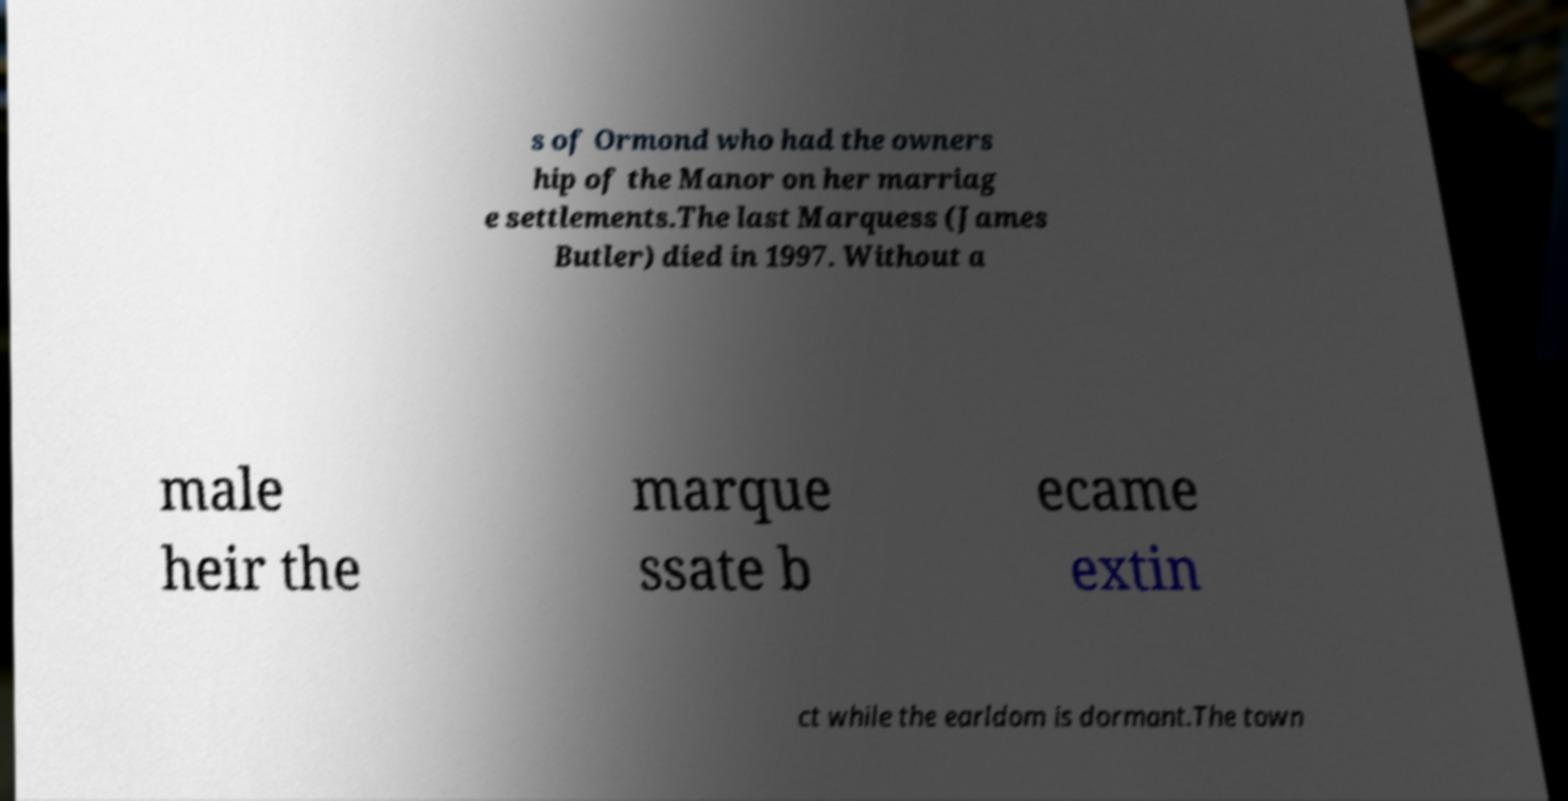Please identify and transcribe the text found in this image. s of Ormond who had the owners hip of the Manor on her marriag e settlements.The last Marquess (James Butler) died in 1997. Without a male heir the marque ssate b ecame extin ct while the earldom is dormant.The town 